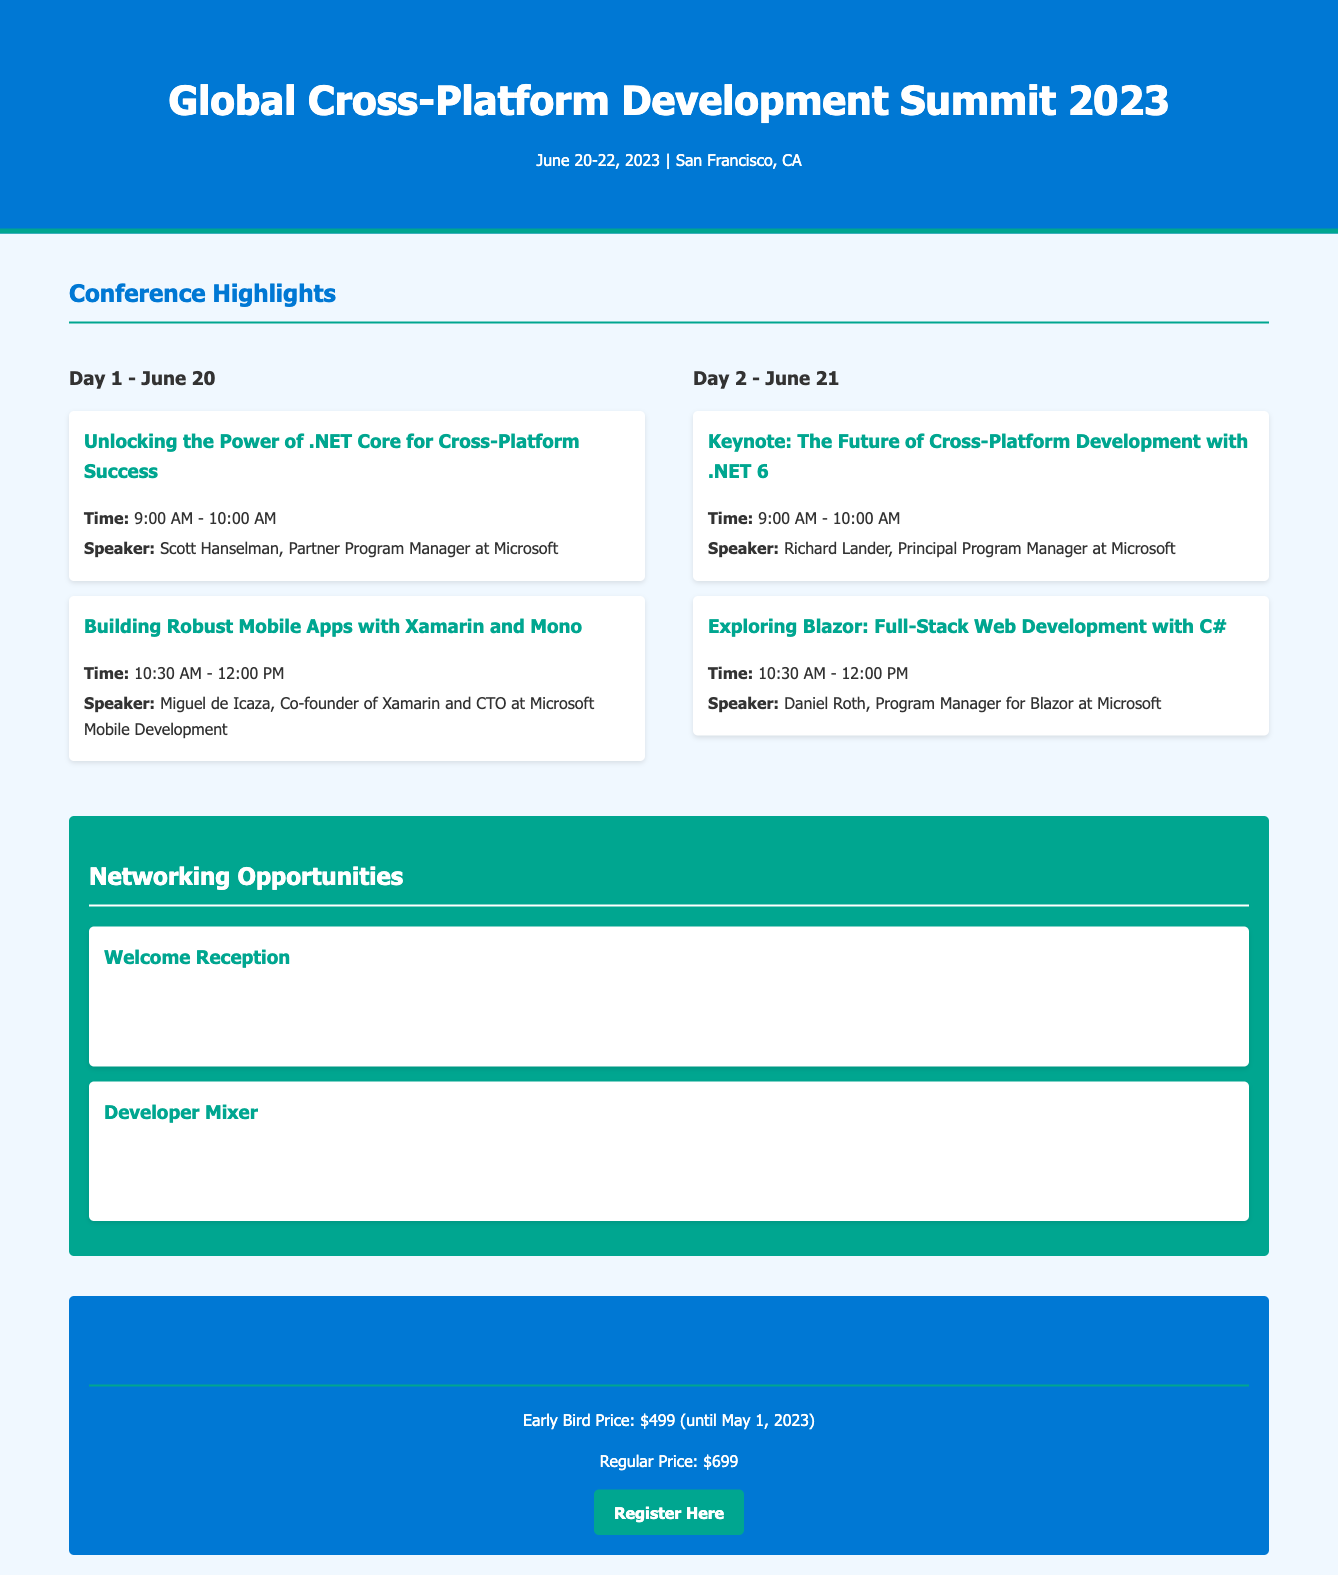What is the date of the conference? The date of the conference is stated in the header of the document as June 20-22, 2023.
Answer: June 20-22, 2023 Who is the keynote speaker on Day 2? The keynote speaker for Day 2 is mentioned in the schedule for that day, which is Richard Lander.
Answer: Richard Lander What time does the "Building Robust Mobile Apps with Xamarin and Mono" session start? The start time for this session is specified in the session details, which is 10:30 AM.
Answer: 10:30 AM What is the location for the Developer Mixer? The location for the Developer Mixer is indicated in the networking opportunities section, which is Sky Lounge, SF Conference Center.
Answer: Sky Lounge, SF Conference Center What is the early bird registration price? The early bird price is mentioned in the registration section of the document, which is $499.
Answer: $499 How long does the Welcome Reception last? The duration of the Welcome Reception can be calculated based on the time given, which is from 5:00 PM to 7:30 PM, lasting for 2.5 hours.
Answer: 2.5 hours What is the regular registration price? The regular price for registration is listed in the registration section as $699.
Answer: $699 Which session on Day 1 features a Microsoft Partner Program Manager? The session that features a Microsoft Partner Program Manager is titled "Unlocking the Power of .NET Core for Cross-Platform Success," with Scott Hanselman as the speaker.
Answer: Unlocking the Power of .NET Core for Cross-Platform Success What opportunity is offered for networking? Networking opportunities are specifically highlighted in the document, such as the Welcome Reception and Developer Mixer.
Answer: Welcome Reception and Developer Mixer 